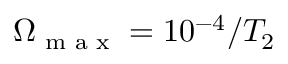<formula> <loc_0><loc_0><loc_500><loc_500>\Omega _ { \max } = 1 0 ^ { - 4 } / T _ { 2 }</formula> 